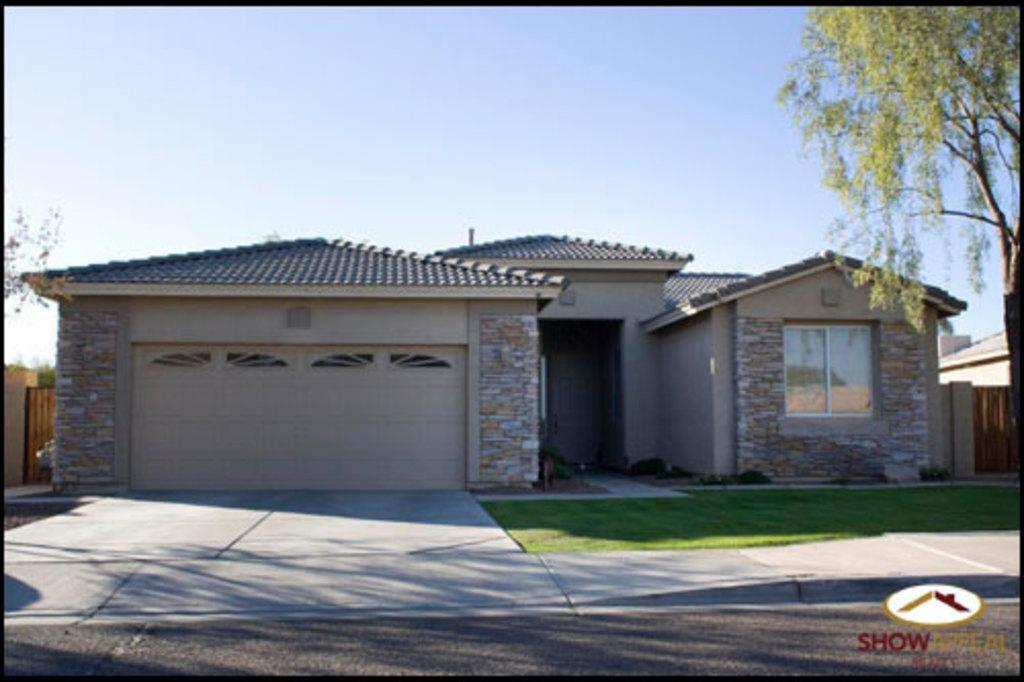What type of structure is in the image? There is a house in the image. What part of the house can be seen in the image? There is a window in the house. What type of terrain is visible in the image? Grass is visible in the image. What type of pathway is present in the image? There is a road in the image. What type of vegetation is present in the image? Trees are present in the image. What part of the natural environment is visible in the image? The sky is visible in the image. What type of representative can be seen in the image? There is no representative present in the image. What type of town is depicted in the image? The image does not depict a town; it shows a house, grass, trees, and other elements. 